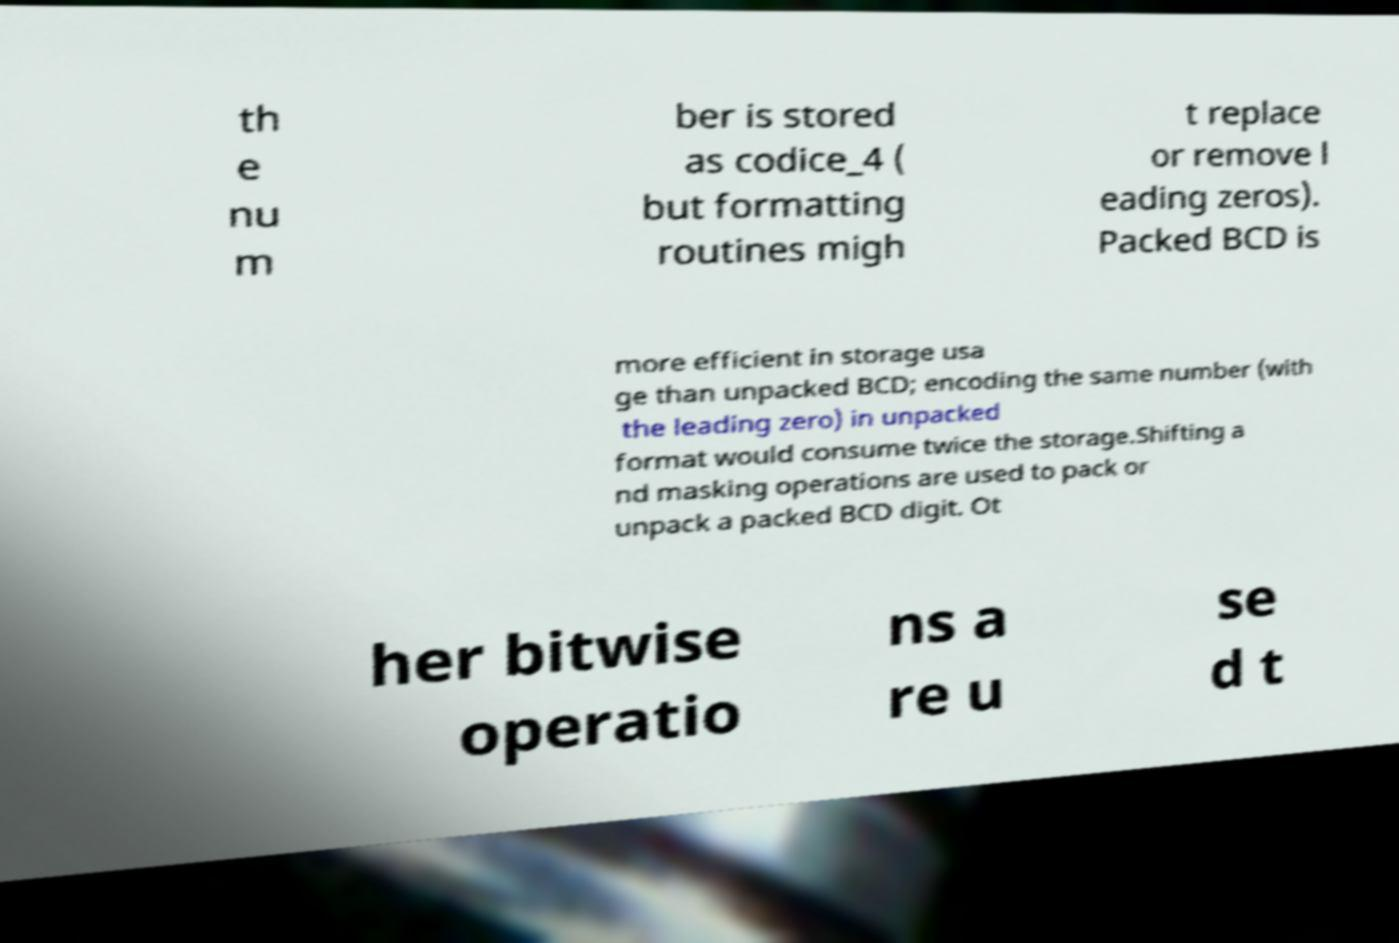I need the written content from this picture converted into text. Can you do that? th e nu m ber is stored as codice_4 ( but formatting routines migh t replace or remove l eading zeros). Packed BCD is more efficient in storage usa ge than unpacked BCD; encoding the same number (with the leading zero) in unpacked format would consume twice the storage.Shifting a nd masking operations are used to pack or unpack a packed BCD digit. Ot her bitwise operatio ns a re u se d t 